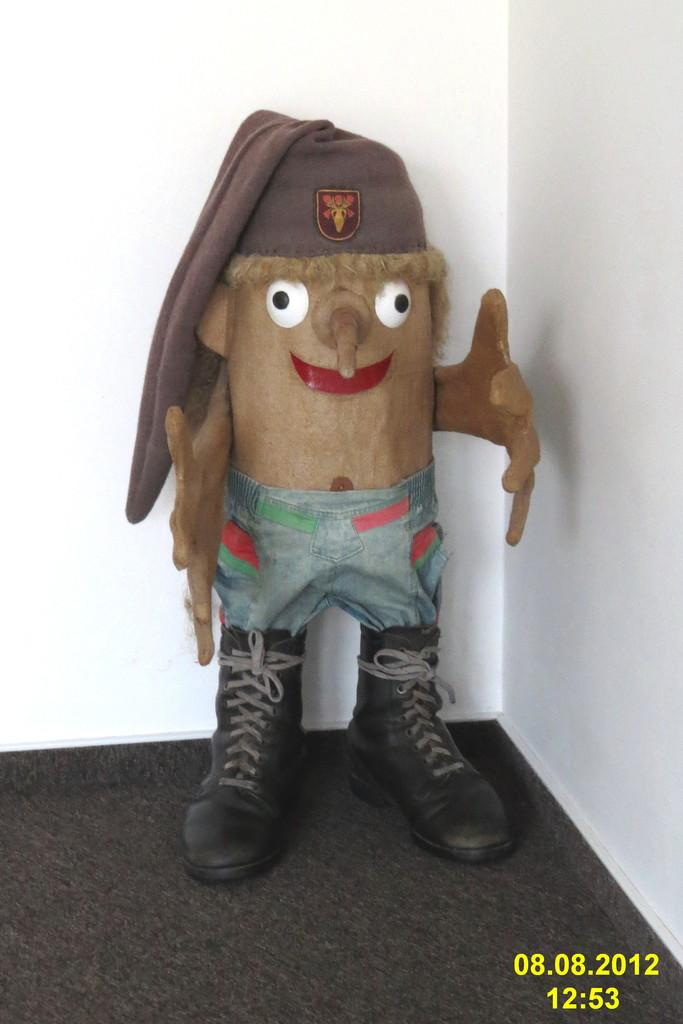What is the main object in the foreground of the image? There is a toy in the foreground of the image. What features does the toy have? The toy has a cap and shoes. What can be seen in the background of the image? There is a white wall in the background of the image. What type of teeth can be seen on the toy in the image? There are no teeth visible on the toy in the image. 